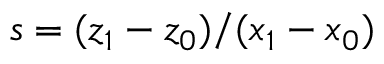<formula> <loc_0><loc_0><loc_500><loc_500>s = ( z _ { 1 } - z _ { 0 } ) / ( x _ { 1 } - x _ { 0 } )</formula> 